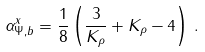<formula> <loc_0><loc_0><loc_500><loc_500>\alpha _ { \Psi , b } ^ { x } = \frac { 1 } { 8 } \left ( \frac { 3 } { K _ { \rho } } + K _ { \rho } - 4 \right ) \, .</formula> 